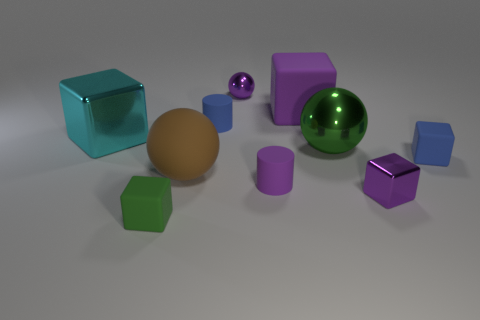What is the material of the big thing that is the same color as the tiny ball?
Provide a succinct answer. Rubber. There is another large thing that is the same shape as the large cyan metal thing; what material is it?
Offer a terse response. Rubber. Are there any tiny brown cylinders made of the same material as the brown thing?
Make the answer very short. No. There is a purple ball; is its size the same as the green thing behind the small blue block?
Your answer should be compact. No. Is there a large metallic cylinder that has the same color as the tiny metal sphere?
Make the answer very short. No. Is the material of the cyan block the same as the small purple block?
Provide a succinct answer. Yes. There is a cyan thing; how many large brown spheres are in front of it?
Your answer should be compact. 1. What material is the object that is left of the tiny purple rubber object and behind the blue matte cylinder?
Your answer should be compact. Metal. How many other purple rubber cylinders are the same size as the purple rubber cylinder?
Your response must be concise. 0. What is the color of the large sphere to the right of the large cube that is behind the cyan object?
Provide a short and direct response. Green. 